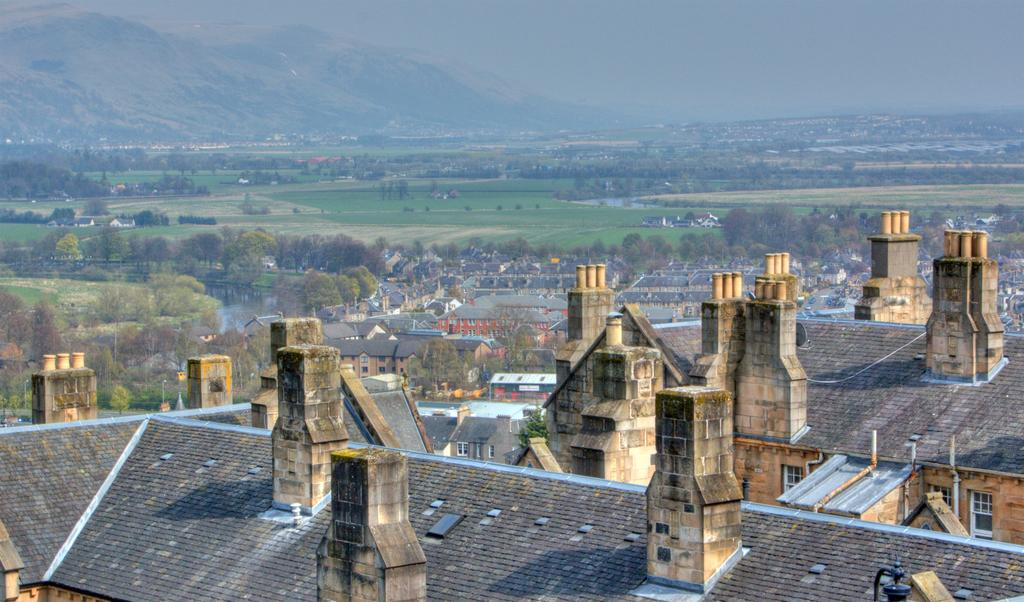What type of structures can be seen in the image? There are buildings in the image. What natural elements are present in the image? There are trees and water visible in the image. What type of geographical feature can be seen in the image? There are mountains in the image. What part of the natural environment is visible in the image? The sky is visible in the image. What type of jeans is the mountain wearing in the image? There are no jeans present in the image, as mountains are geographical features and do not wear clothing. What attraction can be seen in the image? The image does not depict a specific attraction; it shows buildings, trees, water, mountains, and the sky. 